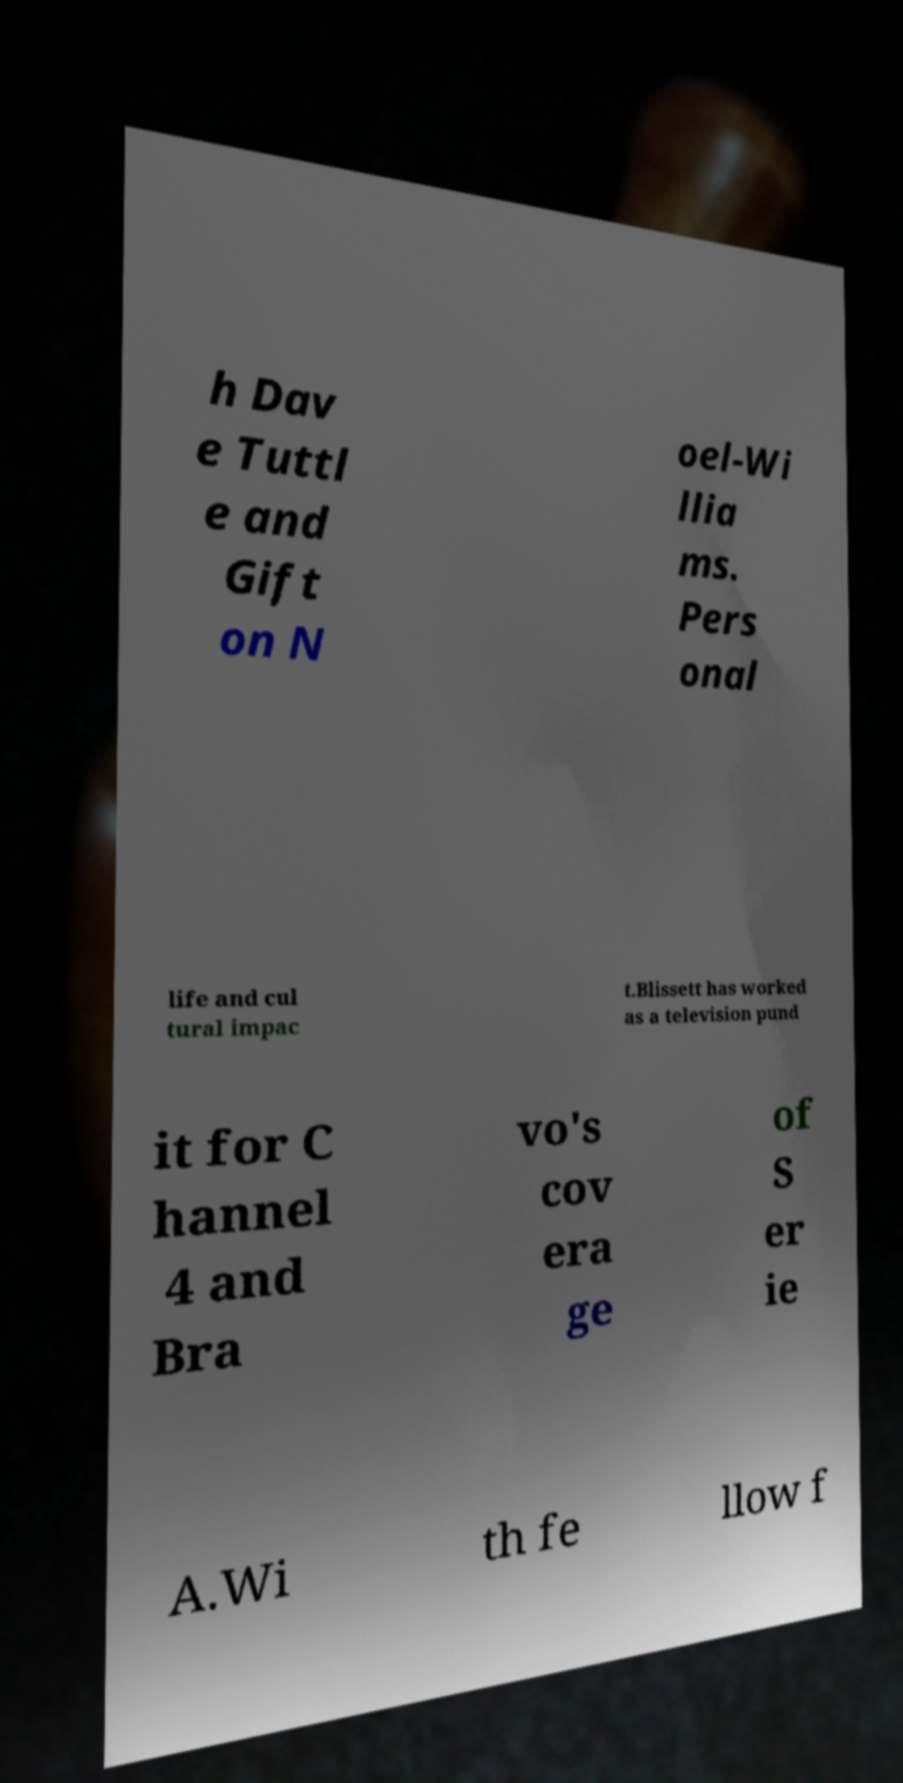Can you read and provide the text displayed in the image?This photo seems to have some interesting text. Can you extract and type it out for me? h Dav e Tuttl e and Gift on N oel-Wi llia ms. Pers onal life and cul tural impac t.Blissett has worked as a television pund it for C hannel 4 and Bra vo's cov era ge of S er ie A.Wi th fe llow f 